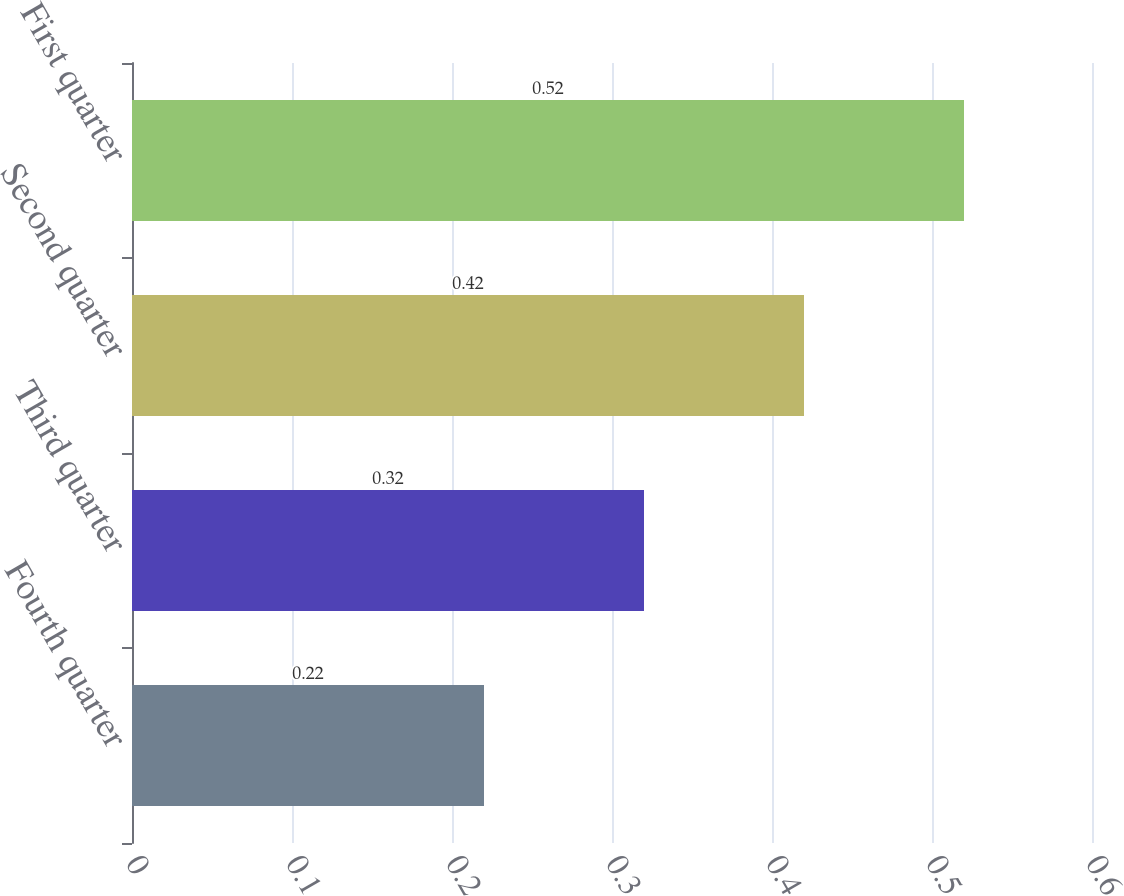<chart> <loc_0><loc_0><loc_500><loc_500><bar_chart><fcel>Fourth quarter<fcel>Third quarter<fcel>Second quarter<fcel>First quarter<nl><fcel>0.22<fcel>0.32<fcel>0.42<fcel>0.52<nl></chart> 